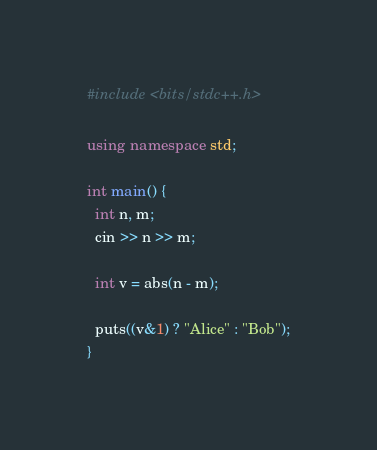Convert code to text. <code><loc_0><loc_0><loc_500><loc_500><_C++_>#include <bits/stdc++.h>

using namespace std;

int main() {
  int n, m;
  cin >> n >> m;

  int v = abs(n - m);

  puts((v&1) ? "Alice" : "Bob");
}</code> 